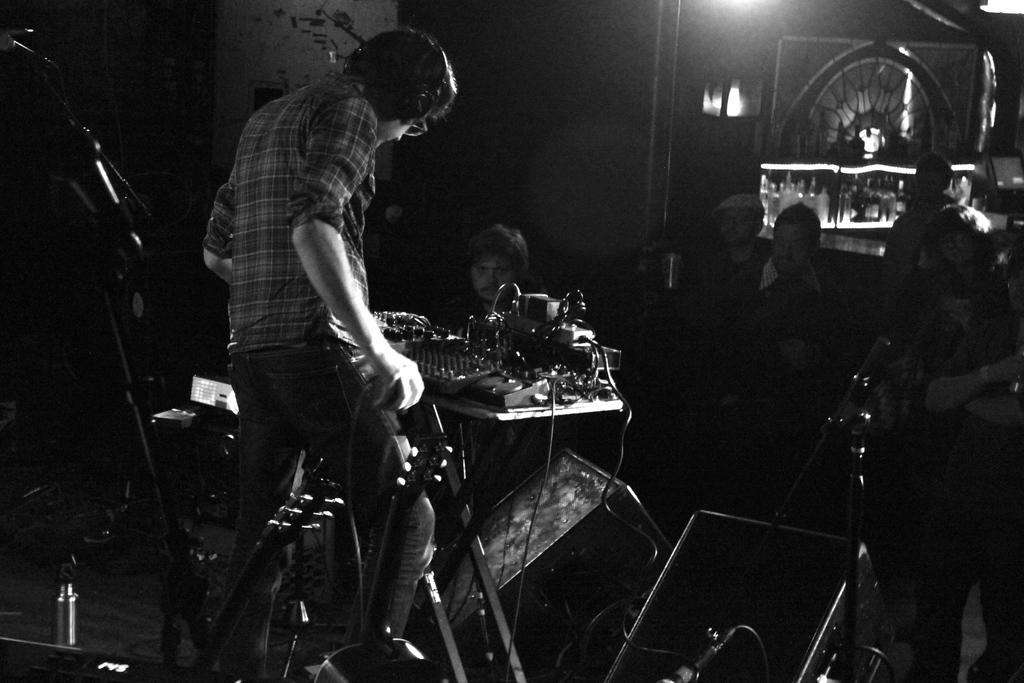What is the color scheme of the image? The image is black and white. What can be seen in the image besides the color scheme? There are people and musical instruments in the image. Where is the mailbox located in the image? There is no mailbox present in the image. What type of bit is being used by the people in the image? There is no bit present in the image, as it is a black and white image featuring people and musical instruments. 